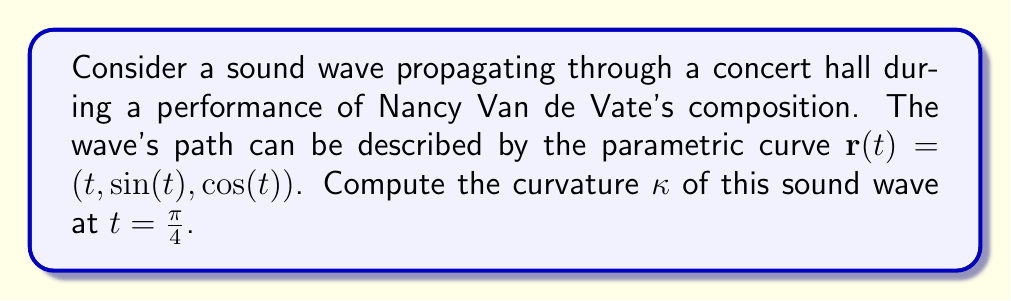Can you solve this math problem? To compute the curvature of the sound wave, we'll follow these steps:

1) The curvature $\kappa$ of a parametric curve $\mathbf{r}(t)$ is given by:

   $$\kappa = \frac{|\mathbf{r}'(t) \times \mathbf{r}''(t)|}{|\mathbf{r}'(t)|^3}$$

2) First, let's calculate $\mathbf{r}'(t)$ and $\mathbf{r}''(t)$:
   
   $\mathbf{r}'(t) = (1, \cos(t), -\sin(t))$
   $\mathbf{r}''(t) = (0, -\sin(t), -\cos(t))$

3) Now, we compute $\mathbf{r}'(t) \times \mathbf{r}''(t)$:

   $$\begin{vmatrix} 
   \mathbf{i} & \mathbf{j} & \mathbf{k} \\
   1 & \cos(t) & -\sin(t) \\
   0 & -\sin(t) & -\cos(t)
   \end{vmatrix}
   = (-\cos^2(t) - \sin^2(t))\mathbf{i} + \sin(t)\mathbf{j} - \cos(t)\mathbf{k}$$

4) The magnitude of this cross product is:

   $|\mathbf{r}'(t) \times \mathbf{r}''(t)| = \sqrt{(\cos^2(t) + \sin^2(t))^2 + \sin^2(t) + \cos^2(t)} = \sqrt{2}$

5) Next, we calculate $|\mathbf{r}'(t)|$:

   $|\mathbf{r}'(t)| = \sqrt{1^2 + \cos^2(t) + \sin^2(t)} = \sqrt{2}$

6) Now we can compute the curvature:

   $$\kappa = \frac{\sqrt{2}}{(\sqrt{2})^3} = \frac{1}{2}$$

7) This result is constant for all $t$, including $t = \frac{\pi}{4}$.
Answer: $\frac{1}{2}$ 